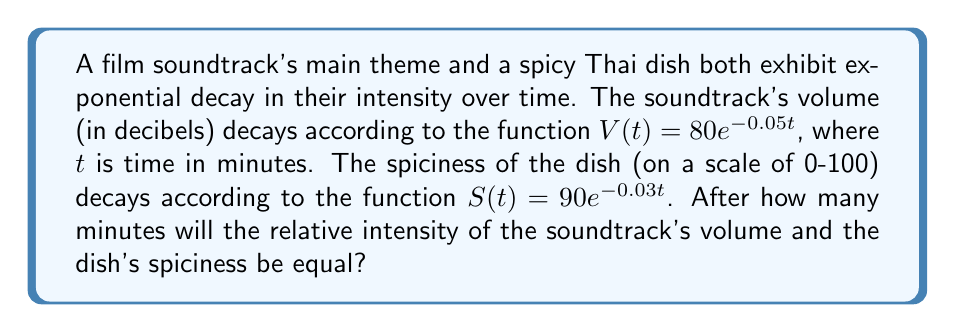Show me your answer to this math problem. To solve this problem, we need to find the time $t$ when the relative intensities of the soundtrack and the dish are equal. We can do this by setting up an equation:

1) First, let's express both functions as a percentage of their initial values:

   Soundtrack: $\frac{V(t)}{V(0)} = \frac{80e^{-0.05t}}{80} = e^{-0.05t}$
   Dish: $\frac{S(t)}{S(0)} = \frac{90e^{-0.03t}}{90} = e^{-0.03t}$

2) Now, we set these equal to each other:

   $e^{-0.05t} = e^{-0.03t}$

3) To solve this, we can take the natural log of both sides:

   $\ln(e^{-0.05t}) = \ln(e^{-0.03t})$

4) The ln and e cancel out:

   $-0.05t = -0.03t$

5) Subtract $-0.03t$ from both sides:

   $-0.02t = 0$

6) Divide both sides by -0.02:

   $t = 0$

The relative intensities are equal at $t = 0$, which means they start at the same relative intensity and diverge from there. To find when they're next equal, we need to consider when they've both completed one full cycle of decay:

7) This occurs when:

   $e^{-0.05t} = e^{-0.03t} = e^{-2\pi}$

8) Solving for t in the first equation:

   $-0.05t = -2\pi$
   $t = \frac{2\pi}{0.05} = 40\pi \approx 125.66$ minutes
Answer: $40\pi$ minutes (approximately 125.66 minutes) 